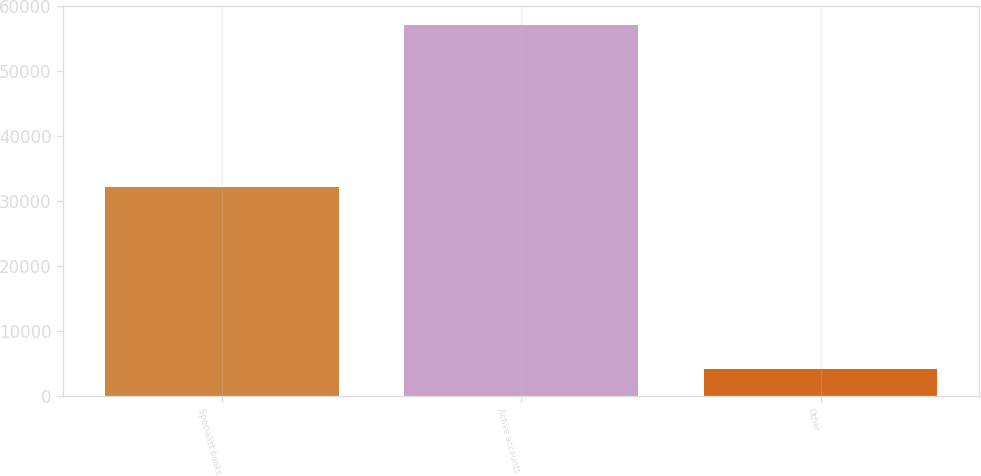Convert chart to OTSL. <chart><loc_0><loc_0><loc_500><loc_500><bar_chart><fcel>Specialist books<fcel>Active accounts<fcel>Other<nl><fcel>32214<fcel>57153<fcel>4034<nl></chart> 